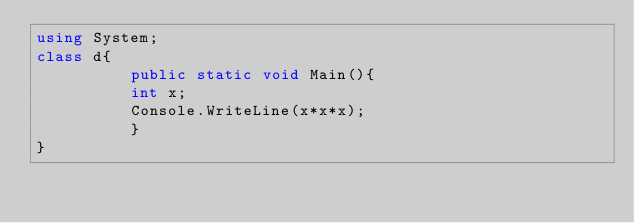Convert code to text. <code><loc_0><loc_0><loc_500><loc_500><_C#_>using System;
class d{
          public static void Main(){
          int x;
          Console.WriteLine(x*x*x);
          }
}</code> 